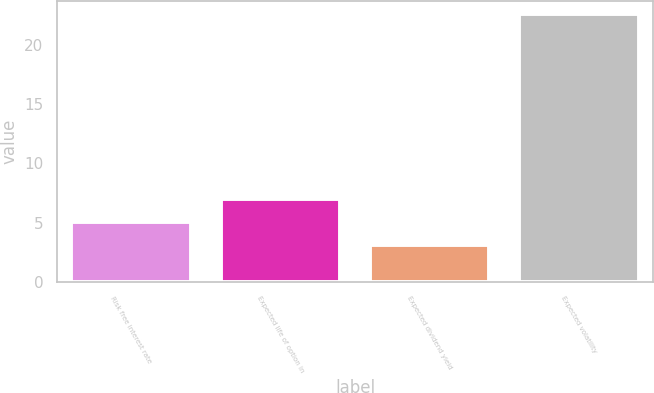Convert chart. <chart><loc_0><loc_0><loc_500><loc_500><bar_chart><fcel>Risk free interest rate<fcel>Expected life of option in<fcel>Expected dividend yield<fcel>Expected volatility<nl><fcel>5.05<fcel>7<fcel>3.1<fcel>22.6<nl></chart> 